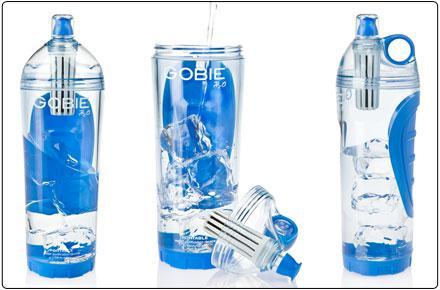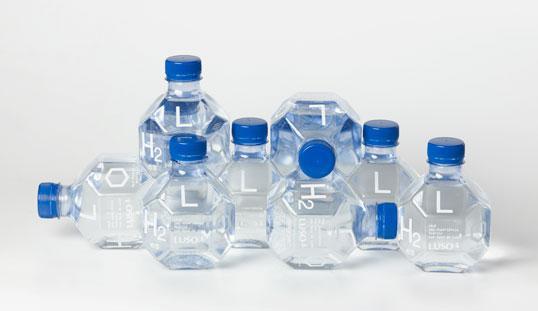The first image is the image on the left, the second image is the image on the right. Analyze the images presented: Is the assertion "All bottles are upright and have lids on them, and at least some bottles have visible labels." valid? Answer yes or no. No. 